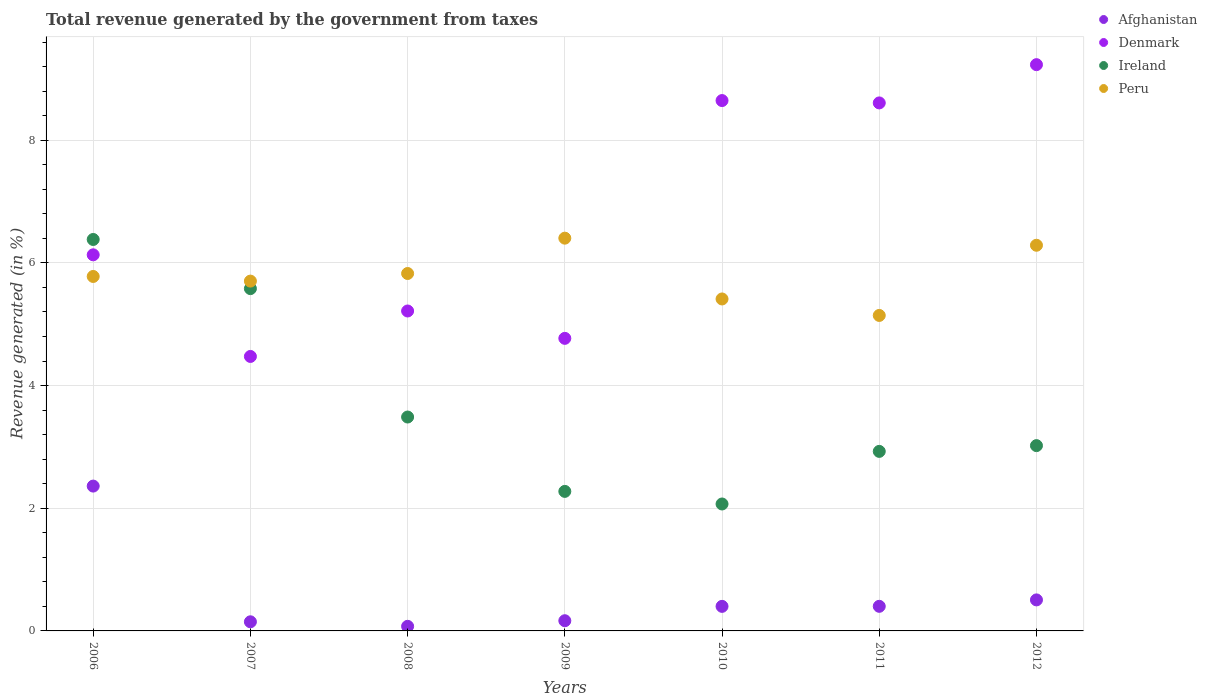How many different coloured dotlines are there?
Give a very brief answer. 4. Is the number of dotlines equal to the number of legend labels?
Offer a very short reply. Yes. What is the total revenue generated in Ireland in 2011?
Your answer should be compact. 2.93. Across all years, what is the maximum total revenue generated in Afghanistan?
Your response must be concise. 2.36. Across all years, what is the minimum total revenue generated in Peru?
Your answer should be compact. 5.14. What is the total total revenue generated in Denmark in the graph?
Your answer should be very brief. 47.08. What is the difference between the total revenue generated in Peru in 2007 and that in 2009?
Offer a very short reply. -0.7. What is the difference between the total revenue generated in Denmark in 2012 and the total revenue generated in Afghanistan in 2008?
Your answer should be compact. 9.16. What is the average total revenue generated in Afghanistan per year?
Offer a very short reply. 0.58. In the year 2006, what is the difference between the total revenue generated in Ireland and total revenue generated in Peru?
Offer a very short reply. 0.6. In how many years, is the total revenue generated in Denmark greater than 0.8 %?
Your answer should be compact. 7. What is the ratio of the total revenue generated in Denmark in 2010 to that in 2012?
Your answer should be compact. 0.94. Is the difference between the total revenue generated in Ireland in 2008 and 2011 greater than the difference between the total revenue generated in Peru in 2008 and 2011?
Make the answer very short. No. What is the difference between the highest and the second highest total revenue generated in Afghanistan?
Offer a terse response. 1.86. What is the difference between the highest and the lowest total revenue generated in Afghanistan?
Your answer should be very brief. 2.29. Is it the case that in every year, the sum of the total revenue generated in Afghanistan and total revenue generated in Peru  is greater than the total revenue generated in Ireland?
Provide a short and direct response. Yes. Does the total revenue generated in Ireland monotonically increase over the years?
Your response must be concise. No. Is the total revenue generated in Afghanistan strictly less than the total revenue generated in Denmark over the years?
Give a very brief answer. Yes. How many dotlines are there?
Offer a very short reply. 4. How many years are there in the graph?
Provide a short and direct response. 7. Does the graph contain any zero values?
Keep it short and to the point. No. Where does the legend appear in the graph?
Your answer should be very brief. Top right. How many legend labels are there?
Your answer should be very brief. 4. What is the title of the graph?
Your answer should be very brief. Total revenue generated by the government from taxes. Does "Bosnia and Herzegovina" appear as one of the legend labels in the graph?
Provide a succinct answer. No. What is the label or title of the X-axis?
Keep it short and to the point. Years. What is the label or title of the Y-axis?
Your answer should be very brief. Revenue generated (in %). What is the Revenue generated (in %) of Afghanistan in 2006?
Offer a very short reply. 2.36. What is the Revenue generated (in %) in Denmark in 2006?
Offer a very short reply. 6.13. What is the Revenue generated (in %) in Ireland in 2006?
Provide a short and direct response. 6.38. What is the Revenue generated (in %) in Peru in 2006?
Provide a succinct answer. 5.78. What is the Revenue generated (in %) in Afghanistan in 2007?
Provide a short and direct response. 0.15. What is the Revenue generated (in %) in Denmark in 2007?
Make the answer very short. 4.47. What is the Revenue generated (in %) of Ireland in 2007?
Provide a succinct answer. 5.58. What is the Revenue generated (in %) of Peru in 2007?
Keep it short and to the point. 5.7. What is the Revenue generated (in %) in Afghanistan in 2008?
Give a very brief answer. 0.08. What is the Revenue generated (in %) in Denmark in 2008?
Your answer should be compact. 5.22. What is the Revenue generated (in %) of Ireland in 2008?
Make the answer very short. 3.49. What is the Revenue generated (in %) of Peru in 2008?
Keep it short and to the point. 5.83. What is the Revenue generated (in %) of Afghanistan in 2009?
Offer a terse response. 0.17. What is the Revenue generated (in %) in Denmark in 2009?
Keep it short and to the point. 4.77. What is the Revenue generated (in %) in Ireland in 2009?
Keep it short and to the point. 2.27. What is the Revenue generated (in %) of Peru in 2009?
Keep it short and to the point. 6.4. What is the Revenue generated (in %) of Afghanistan in 2010?
Provide a short and direct response. 0.4. What is the Revenue generated (in %) of Denmark in 2010?
Offer a very short reply. 8.65. What is the Revenue generated (in %) of Ireland in 2010?
Keep it short and to the point. 2.07. What is the Revenue generated (in %) of Peru in 2010?
Give a very brief answer. 5.41. What is the Revenue generated (in %) in Afghanistan in 2011?
Your answer should be compact. 0.4. What is the Revenue generated (in %) of Denmark in 2011?
Provide a short and direct response. 8.61. What is the Revenue generated (in %) of Ireland in 2011?
Offer a very short reply. 2.93. What is the Revenue generated (in %) of Peru in 2011?
Offer a terse response. 5.14. What is the Revenue generated (in %) of Afghanistan in 2012?
Your response must be concise. 0.51. What is the Revenue generated (in %) of Denmark in 2012?
Provide a succinct answer. 9.23. What is the Revenue generated (in %) in Ireland in 2012?
Offer a terse response. 3.02. What is the Revenue generated (in %) of Peru in 2012?
Make the answer very short. 6.29. Across all years, what is the maximum Revenue generated (in %) in Afghanistan?
Keep it short and to the point. 2.36. Across all years, what is the maximum Revenue generated (in %) in Denmark?
Your answer should be very brief. 9.23. Across all years, what is the maximum Revenue generated (in %) of Ireland?
Ensure brevity in your answer.  6.38. Across all years, what is the maximum Revenue generated (in %) in Peru?
Offer a very short reply. 6.4. Across all years, what is the minimum Revenue generated (in %) of Afghanistan?
Your response must be concise. 0.08. Across all years, what is the minimum Revenue generated (in %) of Denmark?
Keep it short and to the point. 4.47. Across all years, what is the minimum Revenue generated (in %) of Ireland?
Offer a very short reply. 2.07. Across all years, what is the minimum Revenue generated (in %) in Peru?
Your answer should be very brief. 5.14. What is the total Revenue generated (in %) in Afghanistan in the graph?
Offer a very short reply. 4.06. What is the total Revenue generated (in %) of Denmark in the graph?
Provide a short and direct response. 47.08. What is the total Revenue generated (in %) of Ireland in the graph?
Offer a terse response. 25.74. What is the total Revenue generated (in %) of Peru in the graph?
Give a very brief answer. 40.55. What is the difference between the Revenue generated (in %) in Afghanistan in 2006 and that in 2007?
Provide a succinct answer. 2.21. What is the difference between the Revenue generated (in %) in Denmark in 2006 and that in 2007?
Offer a very short reply. 1.66. What is the difference between the Revenue generated (in %) in Ireland in 2006 and that in 2007?
Make the answer very short. 0.8. What is the difference between the Revenue generated (in %) of Peru in 2006 and that in 2007?
Offer a terse response. 0.08. What is the difference between the Revenue generated (in %) in Afghanistan in 2006 and that in 2008?
Keep it short and to the point. 2.29. What is the difference between the Revenue generated (in %) in Denmark in 2006 and that in 2008?
Make the answer very short. 0.92. What is the difference between the Revenue generated (in %) of Ireland in 2006 and that in 2008?
Provide a short and direct response. 2.89. What is the difference between the Revenue generated (in %) of Peru in 2006 and that in 2008?
Your answer should be compact. -0.05. What is the difference between the Revenue generated (in %) of Afghanistan in 2006 and that in 2009?
Your answer should be very brief. 2.19. What is the difference between the Revenue generated (in %) in Denmark in 2006 and that in 2009?
Provide a short and direct response. 1.36. What is the difference between the Revenue generated (in %) in Ireland in 2006 and that in 2009?
Offer a very short reply. 4.11. What is the difference between the Revenue generated (in %) in Peru in 2006 and that in 2009?
Offer a terse response. -0.62. What is the difference between the Revenue generated (in %) of Afghanistan in 2006 and that in 2010?
Make the answer very short. 1.96. What is the difference between the Revenue generated (in %) in Denmark in 2006 and that in 2010?
Ensure brevity in your answer.  -2.51. What is the difference between the Revenue generated (in %) of Ireland in 2006 and that in 2010?
Offer a very short reply. 4.31. What is the difference between the Revenue generated (in %) in Peru in 2006 and that in 2010?
Your answer should be compact. 0.37. What is the difference between the Revenue generated (in %) of Afghanistan in 2006 and that in 2011?
Your answer should be very brief. 1.96. What is the difference between the Revenue generated (in %) in Denmark in 2006 and that in 2011?
Make the answer very short. -2.48. What is the difference between the Revenue generated (in %) in Ireland in 2006 and that in 2011?
Your answer should be compact. 3.45. What is the difference between the Revenue generated (in %) in Peru in 2006 and that in 2011?
Make the answer very short. 0.64. What is the difference between the Revenue generated (in %) of Afghanistan in 2006 and that in 2012?
Give a very brief answer. 1.86. What is the difference between the Revenue generated (in %) of Denmark in 2006 and that in 2012?
Ensure brevity in your answer.  -3.1. What is the difference between the Revenue generated (in %) of Ireland in 2006 and that in 2012?
Your answer should be very brief. 3.36. What is the difference between the Revenue generated (in %) of Peru in 2006 and that in 2012?
Your answer should be very brief. -0.51. What is the difference between the Revenue generated (in %) in Afghanistan in 2007 and that in 2008?
Your answer should be very brief. 0.07. What is the difference between the Revenue generated (in %) of Denmark in 2007 and that in 2008?
Your response must be concise. -0.74. What is the difference between the Revenue generated (in %) of Ireland in 2007 and that in 2008?
Make the answer very short. 2.09. What is the difference between the Revenue generated (in %) in Peru in 2007 and that in 2008?
Keep it short and to the point. -0.12. What is the difference between the Revenue generated (in %) in Afghanistan in 2007 and that in 2009?
Ensure brevity in your answer.  -0.02. What is the difference between the Revenue generated (in %) in Denmark in 2007 and that in 2009?
Your response must be concise. -0.29. What is the difference between the Revenue generated (in %) of Ireland in 2007 and that in 2009?
Your answer should be compact. 3.31. What is the difference between the Revenue generated (in %) in Peru in 2007 and that in 2009?
Ensure brevity in your answer.  -0.7. What is the difference between the Revenue generated (in %) of Afghanistan in 2007 and that in 2010?
Offer a terse response. -0.25. What is the difference between the Revenue generated (in %) of Denmark in 2007 and that in 2010?
Provide a short and direct response. -4.17. What is the difference between the Revenue generated (in %) in Ireland in 2007 and that in 2010?
Make the answer very short. 3.51. What is the difference between the Revenue generated (in %) in Peru in 2007 and that in 2010?
Give a very brief answer. 0.29. What is the difference between the Revenue generated (in %) in Afghanistan in 2007 and that in 2011?
Give a very brief answer. -0.25. What is the difference between the Revenue generated (in %) of Denmark in 2007 and that in 2011?
Provide a succinct answer. -4.13. What is the difference between the Revenue generated (in %) of Ireland in 2007 and that in 2011?
Offer a very short reply. 2.65. What is the difference between the Revenue generated (in %) of Peru in 2007 and that in 2011?
Ensure brevity in your answer.  0.56. What is the difference between the Revenue generated (in %) of Afghanistan in 2007 and that in 2012?
Your response must be concise. -0.36. What is the difference between the Revenue generated (in %) in Denmark in 2007 and that in 2012?
Provide a succinct answer. -4.76. What is the difference between the Revenue generated (in %) in Ireland in 2007 and that in 2012?
Make the answer very short. 2.56. What is the difference between the Revenue generated (in %) of Peru in 2007 and that in 2012?
Your answer should be compact. -0.58. What is the difference between the Revenue generated (in %) of Afghanistan in 2008 and that in 2009?
Your answer should be very brief. -0.09. What is the difference between the Revenue generated (in %) in Denmark in 2008 and that in 2009?
Provide a short and direct response. 0.45. What is the difference between the Revenue generated (in %) of Ireland in 2008 and that in 2009?
Your response must be concise. 1.21. What is the difference between the Revenue generated (in %) of Peru in 2008 and that in 2009?
Your response must be concise. -0.58. What is the difference between the Revenue generated (in %) of Afghanistan in 2008 and that in 2010?
Give a very brief answer. -0.33. What is the difference between the Revenue generated (in %) in Denmark in 2008 and that in 2010?
Ensure brevity in your answer.  -3.43. What is the difference between the Revenue generated (in %) of Ireland in 2008 and that in 2010?
Your answer should be compact. 1.42. What is the difference between the Revenue generated (in %) of Peru in 2008 and that in 2010?
Keep it short and to the point. 0.42. What is the difference between the Revenue generated (in %) of Afghanistan in 2008 and that in 2011?
Offer a very short reply. -0.33. What is the difference between the Revenue generated (in %) in Denmark in 2008 and that in 2011?
Offer a very short reply. -3.39. What is the difference between the Revenue generated (in %) in Ireland in 2008 and that in 2011?
Provide a succinct answer. 0.56. What is the difference between the Revenue generated (in %) in Peru in 2008 and that in 2011?
Your answer should be very brief. 0.68. What is the difference between the Revenue generated (in %) in Afghanistan in 2008 and that in 2012?
Provide a short and direct response. -0.43. What is the difference between the Revenue generated (in %) of Denmark in 2008 and that in 2012?
Provide a succinct answer. -4.02. What is the difference between the Revenue generated (in %) in Ireland in 2008 and that in 2012?
Provide a succinct answer. 0.47. What is the difference between the Revenue generated (in %) of Peru in 2008 and that in 2012?
Offer a terse response. -0.46. What is the difference between the Revenue generated (in %) in Afghanistan in 2009 and that in 2010?
Your answer should be very brief. -0.23. What is the difference between the Revenue generated (in %) of Denmark in 2009 and that in 2010?
Make the answer very short. -3.88. What is the difference between the Revenue generated (in %) of Ireland in 2009 and that in 2010?
Your answer should be compact. 0.21. What is the difference between the Revenue generated (in %) of Afghanistan in 2009 and that in 2011?
Give a very brief answer. -0.23. What is the difference between the Revenue generated (in %) in Denmark in 2009 and that in 2011?
Offer a very short reply. -3.84. What is the difference between the Revenue generated (in %) in Ireland in 2009 and that in 2011?
Your response must be concise. -0.65. What is the difference between the Revenue generated (in %) in Peru in 2009 and that in 2011?
Your answer should be compact. 1.26. What is the difference between the Revenue generated (in %) of Afghanistan in 2009 and that in 2012?
Provide a succinct answer. -0.34. What is the difference between the Revenue generated (in %) of Denmark in 2009 and that in 2012?
Give a very brief answer. -4.46. What is the difference between the Revenue generated (in %) in Ireland in 2009 and that in 2012?
Make the answer very short. -0.75. What is the difference between the Revenue generated (in %) of Peru in 2009 and that in 2012?
Keep it short and to the point. 0.12. What is the difference between the Revenue generated (in %) in Afghanistan in 2010 and that in 2011?
Your answer should be compact. -0. What is the difference between the Revenue generated (in %) of Denmark in 2010 and that in 2011?
Your answer should be compact. 0.04. What is the difference between the Revenue generated (in %) of Ireland in 2010 and that in 2011?
Make the answer very short. -0.86. What is the difference between the Revenue generated (in %) in Peru in 2010 and that in 2011?
Provide a succinct answer. 0.27. What is the difference between the Revenue generated (in %) in Afghanistan in 2010 and that in 2012?
Keep it short and to the point. -0.11. What is the difference between the Revenue generated (in %) of Denmark in 2010 and that in 2012?
Offer a very short reply. -0.59. What is the difference between the Revenue generated (in %) in Ireland in 2010 and that in 2012?
Offer a very short reply. -0.95. What is the difference between the Revenue generated (in %) of Peru in 2010 and that in 2012?
Your answer should be compact. -0.88. What is the difference between the Revenue generated (in %) of Afghanistan in 2011 and that in 2012?
Offer a terse response. -0.1. What is the difference between the Revenue generated (in %) in Denmark in 2011 and that in 2012?
Your answer should be very brief. -0.62. What is the difference between the Revenue generated (in %) in Ireland in 2011 and that in 2012?
Keep it short and to the point. -0.09. What is the difference between the Revenue generated (in %) of Peru in 2011 and that in 2012?
Your answer should be compact. -1.14. What is the difference between the Revenue generated (in %) in Afghanistan in 2006 and the Revenue generated (in %) in Denmark in 2007?
Make the answer very short. -2.11. What is the difference between the Revenue generated (in %) in Afghanistan in 2006 and the Revenue generated (in %) in Ireland in 2007?
Make the answer very short. -3.22. What is the difference between the Revenue generated (in %) in Afghanistan in 2006 and the Revenue generated (in %) in Peru in 2007?
Provide a succinct answer. -3.34. What is the difference between the Revenue generated (in %) in Denmark in 2006 and the Revenue generated (in %) in Ireland in 2007?
Make the answer very short. 0.55. What is the difference between the Revenue generated (in %) of Denmark in 2006 and the Revenue generated (in %) of Peru in 2007?
Offer a terse response. 0.43. What is the difference between the Revenue generated (in %) of Ireland in 2006 and the Revenue generated (in %) of Peru in 2007?
Make the answer very short. 0.68. What is the difference between the Revenue generated (in %) of Afghanistan in 2006 and the Revenue generated (in %) of Denmark in 2008?
Provide a succinct answer. -2.85. What is the difference between the Revenue generated (in %) in Afghanistan in 2006 and the Revenue generated (in %) in Ireland in 2008?
Keep it short and to the point. -1.13. What is the difference between the Revenue generated (in %) of Afghanistan in 2006 and the Revenue generated (in %) of Peru in 2008?
Make the answer very short. -3.47. What is the difference between the Revenue generated (in %) of Denmark in 2006 and the Revenue generated (in %) of Ireland in 2008?
Ensure brevity in your answer.  2.64. What is the difference between the Revenue generated (in %) of Denmark in 2006 and the Revenue generated (in %) of Peru in 2008?
Ensure brevity in your answer.  0.3. What is the difference between the Revenue generated (in %) of Ireland in 2006 and the Revenue generated (in %) of Peru in 2008?
Offer a terse response. 0.55. What is the difference between the Revenue generated (in %) of Afghanistan in 2006 and the Revenue generated (in %) of Denmark in 2009?
Your response must be concise. -2.41. What is the difference between the Revenue generated (in %) in Afghanistan in 2006 and the Revenue generated (in %) in Ireland in 2009?
Provide a short and direct response. 0.09. What is the difference between the Revenue generated (in %) of Afghanistan in 2006 and the Revenue generated (in %) of Peru in 2009?
Give a very brief answer. -4.04. What is the difference between the Revenue generated (in %) of Denmark in 2006 and the Revenue generated (in %) of Ireland in 2009?
Make the answer very short. 3.86. What is the difference between the Revenue generated (in %) in Denmark in 2006 and the Revenue generated (in %) in Peru in 2009?
Ensure brevity in your answer.  -0.27. What is the difference between the Revenue generated (in %) in Ireland in 2006 and the Revenue generated (in %) in Peru in 2009?
Your response must be concise. -0.02. What is the difference between the Revenue generated (in %) in Afghanistan in 2006 and the Revenue generated (in %) in Denmark in 2010?
Your answer should be very brief. -6.29. What is the difference between the Revenue generated (in %) of Afghanistan in 2006 and the Revenue generated (in %) of Ireland in 2010?
Make the answer very short. 0.29. What is the difference between the Revenue generated (in %) of Afghanistan in 2006 and the Revenue generated (in %) of Peru in 2010?
Your answer should be very brief. -3.05. What is the difference between the Revenue generated (in %) in Denmark in 2006 and the Revenue generated (in %) in Ireland in 2010?
Your response must be concise. 4.06. What is the difference between the Revenue generated (in %) of Denmark in 2006 and the Revenue generated (in %) of Peru in 2010?
Give a very brief answer. 0.72. What is the difference between the Revenue generated (in %) in Ireland in 2006 and the Revenue generated (in %) in Peru in 2010?
Make the answer very short. 0.97. What is the difference between the Revenue generated (in %) of Afghanistan in 2006 and the Revenue generated (in %) of Denmark in 2011?
Keep it short and to the point. -6.25. What is the difference between the Revenue generated (in %) of Afghanistan in 2006 and the Revenue generated (in %) of Ireland in 2011?
Provide a short and direct response. -0.57. What is the difference between the Revenue generated (in %) of Afghanistan in 2006 and the Revenue generated (in %) of Peru in 2011?
Give a very brief answer. -2.78. What is the difference between the Revenue generated (in %) in Denmark in 2006 and the Revenue generated (in %) in Ireland in 2011?
Provide a short and direct response. 3.2. What is the difference between the Revenue generated (in %) of Denmark in 2006 and the Revenue generated (in %) of Peru in 2011?
Your response must be concise. 0.99. What is the difference between the Revenue generated (in %) in Ireland in 2006 and the Revenue generated (in %) in Peru in 2011?
Make the answer very short. 1.24. What is the difference between the Revenue generated (in %) in Afghanistan in 2006 and the Revenue generated (in %) in Denmark in 2012?
Make the answer very short. -6.87. What is the difference between the Revenue generated (in %) in Afghanistan in 2006 and the Revenue generated (in %) in Ireland in 2012?
Give a very brief answer. -0.66. What is the difference between the Revenue generated (in %) in Afghanistan in 2006 and the Revenue generated (in %) in Peru in 2012?
Your answer should be compact. -3.93. What is the difference between the Revenue generated (in %) of Denmark in 2006 and the Revenue generated (in %) of Ireland in 2012?
Your answer should be compact. 3.11. What is the difference between the Revenue generated (in %) of Denmark in 2006 and the Revenue generated (in %) of Peru in 2012?
Provide a short and direct response. -0.16. What is the difference between the Revenue generated (in %) of Ireland in 2006 and the Revenue generated (in %) of Peru in 2012?
Give a very brief answer. 0.09. What is the difference between the Revenue generated (in %) of Afghanistan in 2007 and the Revenue generated (in %) of Denmark in 2008?
Your answer should be very brief. -5.07. What is the difference between the Revenue generated (in %) in Afghanistan in 2007 and the Revenue generated (in %) in Ireland in 2008?
Offer a very short reply. -3.34. What is the difference between the Revenue generated (in %) in Afghanistan in 2007 and the Revenue generated (in %) in Peru in 2008?
Your answer should be very brief. -5.68. What is the difference between the Revenue generated (in %) in Denmark in 2007 and the Revenue generated (in %) in Peru in 2008?
Your response must be concise. -1.35. What is the difference between the Revenue generated (in %) of Ireland in 2007 and the Revenue generated (in %) of Peru in 2008?
Make the answer very short. -0.25. What is the difference between the Revenue generated (in %) of Afghanistan in 2007 and the Revenue generated (in %) of Denmark in 2009?
Offer a terse response. -4.62. What is the difference between the Revenue generated (in %) in Afghanistan in 2007 and the Revenue generated (in %) in Ireland in 2009?
Make the answer very short. -2.13. What is the difference between the Revenue generated (in %) in Afghanistan in 2007 and the Revenue generated (in %) in Peru in 2009?
Make the answer very short. -6.25. What is the difference between the Revenue generated (in %) in Denmark in 2007 and the Revenue generated (in %) in Peru in 2009?
Keep it short and to the point. -1.93. What is the difference between the Revenue generated (in %) of Ireland in 2007 and the Revenue generated (in %) of Peru in 2009?
Provide a succinct answer. -0.82. What is the difference between the Revenue generated (in %) of Afghanistan in 2007 and the Revenue generated (in %) of Denmark in 2010?
Make the answer very short. -8.5. What is the difference between the Revenue generated (in %) in Afghanistan in 2007 and the Revenue generated (in %) in Ireland in 2010?
Provide a succinct answer. -1.92. What is the difference between the Revenue generated (in %) of Afghanistan in 2007 and the Revenue generated (in %) of Peru in 2010?
Your answer should be compact. -5.26. What is the difference between the Revenue generated (in %) in Denmark in 2007 and the Revenue generated (in %) in Ireland in 2010?
Your answer should be very brief. 2.41. What is the difference between the Revenue generated (in %) in Denmark in 2007 and the Revenue generated (in %) in Peru in 2010?
Provide a succinct answer. -0.94. What is the difference between the Revenue generated (in %) of Ireland in 2007 and the Revenue generated (in %) of Peru in 2010?
Make the answer very short. 0.17. What is the difference between the Revenue generated (in %) of Afghanistan in 2007 and the Revenue generated (in %) of Denmark in 2011?
Keep it short and to the point. -8.46. What is the difference between the Revenue generated (in %) in Afghanistan in 2007 and the Revenue generated (in %) in Ireland in 2011?
Provide a succinct answer. -2.78. What is the difference between the Revenue generated (in %) in Afghanistan in 2007 and the Revenue generated (in %) in Peru in 2011?
Keep it short and to the point. -4.99. What is the difference between the Revenue generated (in %) of Denmark in 2007 and the Revenue generated (in %) of Ireland in 2011?
Your answer should be compact. 1.55. What is the difference between the Revenue generated (in %) of Denmark in 2007 and the Revenue generated (in %) of Peru in 2011?
Offer a terse response. -0.67. What is the difference between the Revenue generated (in %) of Ireland in 2007 and the Revenue generated (in %) of Peru in 2011?
Offer a terse response. 0.44. What is the difference between the Revenue generated (in %) of Afghanistan in 2007 and the Revenue generated (in %) of Denmark in 2012?
Your answer should be compact. -9.08. What is the difference between the Revenue generated (in %) in Afghanistan in 2007 and the Revenue generated (in %) in Ireland in 2012?
Ensure brevity in your answer.  -2.87. What is the difference between the Revenue generated (in %) in Afghanistan in 2007 and the Revenue generated (in %) in Peru in 2012?
Your response must be concise. -6.14. What is the difference between the Revenue generated (in %) of Denmark in 2007 and the Revenue generated (in %) of Ireland in 2012?
Provide a short and direct response. 1.45. What is the difference between the Revenue generated (in %) in Denmark in 2007 and the Revenue generated (in %) in Peru in 2012?
Provide a succinct answer. -1.81. What is the difference between the Revenue generated (in %) in Ireland in 2007 and the Revenue generated (in %) in Peru in 2012?
Offer a very short reply. -0.71. What is the difference between the Revenue generated (in %) of Afghanistan in 2008 and the Revenue generated (in %) of Denmark in 2009?
Provide a short and direct response. -4.69. What is the difference between the Revenue generated (in %) in Afghanistan in 2008 and the Revenue generated (in %) in Ireland in 2009?
Ensure brevity in your answer.  -2.2. What is the difference between the Revenue generated (in %) of Afghanistan in 2008 and the Revenue generated (in %) of Peru in 2009?
Provide a succinct answer. -6.33. What is the difference between the Revenue generated (in %) in Denmark in 2008 and the Revenue generated (in %) in Ireland in 2009?
Offer a very short reply. 2.94. What is the difference between the Revenue generated (in %) of Denmark in 2008 and the Revenue generated (in %) of Peru in 2009?
Offer a very short reply. -1.19. What is the difference between the Revenue generated (in %) of Ireland in 2008 and the Revenue generated (in %) of Peru in 2009?
Provide a succinct answer. -2.92. What is the difference between the Revenue generated (in %) in Afghanistan in 2008 and the Revenue generated (in %) in Denmark in 2010?
Make the answer very short. -8.57. What is the difference between the Revenue generated (in %) in Afghanistan in 2008 and the Revenue generated (in %) in Ireland in 2010?
Provide a short and direct response. -1.99. What is the difference between the Revenue generated (in %) of Afghanistan in 2008 and the Revenue generated (in %) of Peru in 2010?
Your answer should be very brief. -5.34. What is the difference between the Revenue generated (in %) in Denmark in 2008 and the Revenue generated (in %) in Ireland in 2010?
Give a very brief answer. 3.15. What is the difference between the Revenue generated (in %) of Denmark in 2008 and the Revenue generated (in %) of Peru in 2010?
Offer a very short reply. -0.2. What is the difference between the Revenue generated (in %) in Ireland in 2008 and the Revenue generated (in %) in Peru in 2010?
Provide a short and direct response. -1.92. What is the difference between the Revenue generated (in %) of Afghanistan in 2008 and the Revenue generated (in %) of Denmark in 2011?
Your answer should be compact. -8.53. What is the difference between the Revenue generated (in %) of Afghanistan in 2008 and the Revenue generated (in %) of Ireland in 2011?
Your response must be concise. -2.85. What is the difference between the Revenue generated (in %) of Afghanistan in 2008 and the Revenue generated (in %) of Peru in 2011?
Give a very brief answer. -5.07. What is the difference between the Revenue generated (in %) in Denmark in 2008 and the Revenue generated (in %) in Ireland in 2011?
Offer a very short reply. 2.29. What is the difference between the Revenue generated (in %) of Denmark in 2008 and the Revenue generated (in %) of Peru in 2011?
Offer a very short reply. 0.07. What is the difference between the Revenue generated (in %) of Ireland in 2008 and the Revenue generated (in %) of Peru in 2011?
Offer a very short reply. -1.66. What is the difference between the Revenue generated (in %) in Afghanistan in 2008 and the Revenue generated (in %) in Denmark in 2012?
Give a very brief answer. -9.16. What is the difference between the Revenue generated (in %) of Afghanistan in 2008 and the Revenue generated (in %) of Ireland in 2012?
Keep it short and to the point. -2.95. What is the difference between the Revenue generated (in %) in Afghanistan in 2008 and the Revenue generated (in %) in Peru in 2012?
Ensure brevity in your answer.  -6.21. What is the difference between the Revenue generated (in %) of Denmark in 2008 and the Revenue generated (in %) of Ireland in 2012?
Ensure brevity in your answer.  2.19. What is the difference between the Revenue generated (in %) in Denmark in 2008 and the Revenue generated (in %) in Peru in 2012?
Provide a succinct answer. -1.07. What is the difference between the Revenue generated (in %) in Ireland in 2008 and the Revenue generated (in %) in Peru in 2012?
Provide a succinct answer. -2.8. What is the difference between the Revenue generated (in %) of Afghanistan in 2009 and the Revenue generated (in %) of Denmark in 2010?
Your response must be concise. -8.48. What is the difference between the Revenue generated (in %) in Afghanistan in 2009 and the Revenue generated (in %) in Ireland in 2010?
Offer a terse response. -1.9. What is the difference between the Revenue generated (in %) in Afghanistan in 2009 and the Revenue generated (in %) in Peru in 2010?
Provide a succinct answer. -5.25. What is the difference between the Revenue generated (in %) in Denmark in 2009 and the Revenue generated (in %) in Ireland in 2010?
Provide a short and direct response. 2.7. What is the difference between the Revenue generated (in %) of Denmark in 2009 and the Revenue generated (in %) of Peru in 2010?
Provide a succinct answer. -0.64. What is the difference between the Revenue generated (in %) in Ireland in 2009 and the Revenue generated (in %) in Peru in 2010?
Offer a very short reply. -3.14. What is the difference between the Revenue generated (in %) of Afghanistan in 2009 and the Revenue generated (in %) of Denmark in 2011?
Your answer should be compact. -8.44. What is the difference between the Revenue generated (in %) in Afghanistan in 2009 and the Revenue generated (in %) in Ireland in 2011?
Your response must be concise. -2.76. What is the difference between the Revenue generated (in %) of Afghanistan in 2009 and the Revenue generated (in %) of Peru in 2011?
Provide a short and direct response. -4.98. What is the difference between the Revenue generated (in %) of Denmark in 2009 and the Revenue generated (in %) of Ireland in 2011?
Provide a short and direct response. 1.84. What is the difference between the Revenue generated (in %) in Denmark in 2009 and the Revenue generated (in %) in Peru in 2011?
Offer a very short reply. -0.37. What is the difference between the Revenue generated (in %) in Ireland in 2009 and the Revenue generated (in %) in Peru in 2011?
Keep it short and to the point. -2.87. What is the difference between the Revenue generated (in %) of Afghanistan in 2009 and the Revenue generated (in %) of Denmark in 2012?
Keep it short and to the point. -9.07. What is the difference between the Revenue generated (in %) of Afghanistan in 2009 and the Revenue generated (in %) of Ireland in 2012?
Offer a very short reply. -2.85. What is the difference between the Revenue generated (in %) of Afghanistan in 2009 and the Revenue generated (in %) of Peru in 2012?
Ensure brevity in your answer.  -6.12. What is the difference between the Revenue generated (in %) in Denmark in 2009 and the Revenue generated (in %) in Ireland in 2012?
Offer a very short reply. 1.75. What is the difference between the Revenue generated (in %) in Denmark in 2009 and the Revenue generated (in %) in Peru in 2012?
Your answer should be compact. -1.52. What is the difference between the Revenue generated (in %) of Ireland in 2009 and the Revenue generated (in %) of Peru in 2012?
Provide a short and direct response. -4.01. What is the difference between the Revenue generated (in %) in Afghanistan in 2010 and the Revenue generated (in %) in Denmark in 2011?
Provide a succinct answer. -8.21. What is the difference between the Revenue generated (in %) of Afghanistan in 2010 and the Revenue generated (in %) of Ireland in 2011?
Ensure brevity in your answer.  -2.53. What is the difference between the Revenue generated (in %) in Afghanistan in 2010 and the Revenue generated (in %) in Peru in 2011?
Keep it short and to the point. -4.74. What is the difference between the Revenue generated (in %) of Denmark in 2010 and the Revenue generated (in %) of Ireland in 2011?
Your response must be concise. 5.72. What is the difference between the Revenue generated (in %) of Denmark in 2010 and the Revenue generated (in %) of Peru in 2011?
Your answer should be very brief. 3.5. What is the difference between the Revenue generated (in %) of Ireland in 2010 and the Revenue generated (in %) of Peru in 2011?
Offer a terse response. -3.07. What is the difference between the Revenue generated (in %) of Afghanistan in 2010 and the Revenue generated (in %) of Denmark in 2012?
Make the answer very short. -8.83. What is the difference between the Revenue generated (in %) in Afghanistan in 2010 and the Revenue generated (in %) in Ireland in 2012?
Your answer should be very brief. -2.62. What is the difference between the Revenue generated (in %) in Afghanistan in 2010 and the Revenue generated (in %) in Peru in 2012?
Your response must be concise. -5.89. What is the difference between the Revenue generated (in %) of Denmark in 2010 and the Revenue generated (in %) of Ireland in 2012?
Provide a succinct answer. 5.63. What is the difference between the Revenue generated (in %) of Denmark in 2010 and the Revenue generated (in %) of Peru in 2012?
Keep it short and to the point. 2.36. What is the difference between the Revenue generated (in %) in Ireland in 2010 and the Revenue generated (in %) in Peru in 2012?
Ensure brevity in your answer.  -4.22. What is the difference between the Revenue generated (in %) in Afghanistan in 2011 and the Revenue generated (in %) in Denmark in 2012?
Make the answer very short. -8.83. What is the difference between the Revenue generated (in %) of Afghanistan in 2011 and the Revenue generated (in %) of Ireland in 2012?
Your answer should be very brief. -2.62. What is the difference between the Revenue generated (in %) of Afghanistan in 2011 and the Revenue generated (in %) of Peru in 2012?
Give a very brief answer. -5.89. What is the difference between the Revenue generated (in %) in Denmark in 2011 and the Revenue generated (in %) in Ireland in 2012?
Keep it short and to the point. 5.59. What is the difference between the Revenue generated (in %) in Denmark in 2011 and the Revenue generated (in %) in Peru in 2012?
Make the answer very short. 2.32. What is the difference between the Revenue generated (in %) of Ireland in 2011 and the Revenue generated (in %) of Peru in 2012?
Offer a terse response. -3.36. What is the average Revenue generated (in %) in Afghanistan per year?
Your response must be concise. 0.58. What is the average Revenue generated (in %) in Denmark per year?
Your answer should be compact. 6.73. What is the average Revenue generated (in %) in Ireland per year?
Keep it short and to the point. 3.68. What is the average Revenue generated (in %) of Peru per year?
Your answer should be very brief. 5.79. In the year 2006, what is the difference between the Revenue generated (in %) of Afghanistan and Revenue generated (in %) of Denmark?
Your answer should be compact. -3.77. In the year 2006, what is the difference between the Revenue generated (in %) of Afghanistan and Revenue generated (in %) of Ireland?
Provide a succinct answer. -4.02. In the year 2006, what is the difference between the Revenue generated (in %) of Afghanistan and Revenue generated (in %) of Peru?
Your response must be concise. -3.42. In the year 2006, what is the difference between the Revenue generated (in %) in Denmark and Revenue generated (in %) in Ireland?
Offer a very short reply. -0.25. In the year 2006, what is the difference between the Revenue generated (in %) in Denmark and Revenue generated (in %) in Peru?
Offer a very short reply. 0.35. In the year 2006, what is the difference between the Revenue generated (in %) in Ireland and Revenue generated (in %) in Peru?
Provide a short and direct response. 0.6. In the year 2007, what is the difference between the Revenue generated (in %) of Afghanistan and Revenue generated (in %) of Denmark?
Provide a short and direct response. -4.33. In the year 2007, what is the difference between the Revenue generated (in %) in Afghanistan and Revenue generated (in %) in Ireland?
Make the answer very short. -5.43. In the year 2007, what is the difference between the Revenue generated (in %) of Afghanistan and Revenue generated (in %) of Peru?
Offer a very short reply. -5.55. In the year 2007, what is the difference between the Revenue generated (in %) in Denmark and Revenue generated (in %) in Ireland?
Your response must be concise. -1.11. In the year 2007, what is the difference between the Revenue generated (in %) of Denmark and Revenue generated (in %) of Peru?
Keep it short and to the point. -1.23. In the year 2007, what is the difference between the Revenue generated (in %) in Ireland and Revenue generated (in %) in Peru?
Provide a succinct answer. -0.12. In the year 2008, what is the difference between the Revenue generated (in %) in Afghanistan and Revenue generated (in %) in Denmark?
Your answer should be compact. -5.14. In the year 2008, what is the difference between the Revenue generated (in %) of Afghanistan and Revenue generated (in %) of Ireland?
Keep it short and to the point. -3.41. In the year 2008, what is the difference between the Revenue generated (in %) of Afghanistan and Revenue generated (in %) of Peru?
Your response must be concise. -5.75. In the year 2008, what is the difference between the Revenue generated (in %) of Denmark and Revenue generated (in %) of Ireland?
Give a very brief answer. 1.73. In the year 2008, what is the difference between the Revenue generated (in %) of Denmark and Revenue generated (in %) of Peru?
Offer a terse response. -0.61. In the year 2008, what is the difference between the Revenue generated (in %) in Ireland and Revenue generated (in %) in Peru?
Your response must be concise. -2.34. In the year 2009, what is the difference between the Revenue generated (in %) of Afghanistan and Revenue generated (in %) of Denmark?
Your answer should be compact. -4.6. In the year 2009, what is the difference between the Revenue generated (in %) in Afghanistan and Revenue generated (in %) in Ireland?
Your answer should be compact. -2.11. In the year 2009, what is the difference between the Revenue generated (in %) of Afghanistan and Revenue generated (in %) of Peru?
Provide a succinct answer. -6.24. In the year 2009, what is the difference between the Revenue generated (in %) of Denmark and Revenue generated (in %) of Ireland?
Give a very brief answer. 2.49. In the year 2009, what is the difference between the Revenue generated (in %) of Denmark and Revenue generated (in %) of Peru?
Make the answer very short. -1.63. In the year 2009, what is the difference between the Revenue generated (in %) of Ireland and Revenue generated (in %) of Peru?
Make the answer very short. -4.13. In the year 2010, what is the difference between the Revenue generated (in %) in Afghanistan and Revenue generated (in %) in Denmark?
Keep it short and to the point. -8.25. In the year 2010, what is the difference between the Revenue generated (in %) in Afghanistan and Revenue generated (in %) in Ireland?
Offer a very short reply. -1.67. In the year 2010, what is the difference between the Revenue generated (in %) in Afghanistan and Revenue generated (in %) in Peru?
Keep it short and to the point. -5.01. In the year 2010, what is the difference between the Revenue generated (in %) in Denmark and Revenue generated (in %) in Ireland?
Make the answer very short. 6.58. In the year 2010, what is the difference between the Revenue generated (in %) in Denmark and Revenue generated (in %) in Peru?
Provide a succinct answer. 3.23. In the year 2010, what is the difference between the Revenue generated (in %) in Ireland and Revenue generated (in %) in Peru?
Your answer should be compact. -3.34. In the year 2011, what is the difference between the Revenue generated (in %) of Afghanistan and Revenue generated (in %) of Denmark?
Ensure brevity in your answer.  -8.21. In the year 2011, what is the difference between the Revenue generated (in %) of Afghanistan and Revenue generated (in %) of Ireland?
Give a very brief answer. -2.53. In the year 2011, what is the difference between the Revenue generated (in %) of Afghanistan and Revenue generated (in %) of Peru?
Offer a very short reply. -4.74. In the year 2011, what is the difference between the Revenue generated (in %) of Denmark and Revenue generated (in %) of Ireland?
Ensure brevity in your answer.  5.68. In the year 2011, what is the difference between the Revenue generated (in %) of Denmark and Revenue generated (in %) of Peru?
Give a very brief answer. 3.46. In the year 2011, what is the difference between the Revenue generated (in %) of Ireland and Revenue generated (in %) of Peru?
Your answer should be compact. -2.22. In the year 2012, what is the difference between the Revenue generated (in %) in Afghanistan and Revenue generated (in %) in Denmark?
Your response must be concise. -8.73. In the year 2012, what is the difference between the Revenue generated (in %) of Afghanistan and Revenue generated (in %) of Ireland?
Keep it short and to the point. -2.52. In the year 2012, what is the difference between the Revenue generated (in %) of Afghanistan and Revenue generated (in %) of Peru?
Provide a succinct answer. -5.78. In the year 2012, what is the difference between the Revenue generated (in %) in Denmark and Revenue generated (in %) in Ireland?
Provide a short and direct response. 6.21. In the year 2012, what is the difference between the Revenue generated (in %) in Denmark and Revenue generated (in %) in Peru?
Ensure brevity in your answer.  2.94. In the year 2012, what is the difference between the Revenue generated (in %) of Ireland and Revenue generated (in %) of Peru?
Give a very brief answer. -3.27. What is the ratio of the Revenue generated (in %) of Afghanistan in 2006 to that in 2007?
Offer a very short reply. 15.87. What is the ratio of the Revenue generated (in %) of Denmark in 2006 to that in 2007?
Provide a short and direct response. 1.37. What is the ratio of the Revenue generated (in %) in Ireland in 2006 to that in 2007?
Your response must be concise. 1.14. What is the ratio of the Revenue generated (in %) of Peru in 2006 to that in 2007?
Your answer should be compact. 1.01. What is the ratio of the Revenue generated (in %) in Afghanistan in 2006 to that in 2008?
Offer a terse response. 31.44. What is the ratio of the Revenue generated (in %) in Denmark in 2006 to that in 2008?
Provide a short and direct response. 1.18. What is the ratio of the Revenue generated (in %) in Ireland in 2006 to that in 2008?
Make the answer very short. 1.83. What is the ratio of the Revenue generated (in %) of Afghanistan in 2006 to that in 2009?
Ensure brevity in your answer.  14.21. What is the ratio of the Revenue generated (in %) of Denmark in 2006 to that in 2009?
Make the answer very short. 1.29. What is the ratio of the Revenue generated (in %) of Ireland in 2006 to that in 2009?
Ensure brevity in your answer.  2.81. What is the ratio of the Revenue generated (in %) in Peru in 2006 to that in 2009?
Provide a short and direct response. 0.9. What is the ratio of the Revenue generated (in %) in Afghanistan in 2006 to that in 2010?
Provide a short and direct response. 5.9. What is the ratio of the Revenue generated (in %) in Denmark in 2006 to that in 2010?
Offer a very short reply. 0.71. What is the ratio of the Revenue generated (in %) in Ireland in 2006 to that in 2010?
Your answer should be very brief. 3.08. What is the ratio of the Revenue generated (in %) in Peru in 2006 to that in 2010?
Your answer should be compact. 1.07. What is the ratio of the Revenue generated (in %) in Afghanistan in 2006 to that in 2011?
Provide a short and direct response. 5.89. What is the ratio of the Revenue generated (in %) of Denmark in 2006 to that in 2011?
Make the answer very short. 0.71. What is the ratio of the Revenue generated (in %) of Ireland in 2006 to that in 2011?
Provide a short and direct response. 2.18. What is the ratio of the Revenue generated (in %) in Peru in 2006 to that in 2011?
Provide a short and direct response. 1.12. What is the ratio of the Revenue generated (in %) of Afghanistan in 2006 to that in 2012?
Your response must be concise. 4.67. What is the ratio of the Revenue generated (in %) of Denmark in 2006 to that in 2012?
Make the answer very short. 0.66. What is the ratio of the Revenue generated (in %) of Ireland in 2006 to that in 2012?
Your answer should be compact. 2.11. What is the ratio of the Revenue generated (in %) in Peru in 2006 to that in 2012?
Provide a short and direct response. 0.92. What is the ratio of the Revenue generated (in %) of Afghanistan in 2007 to that in 2008?
Your response must be concise. 1.98. What is the ratio of the Revenue generated (in %) of Denmark in 2007 to that in 2008?
Ensure brevity in your answer.  0.86. What is the ratio of the Revenue generated (in %) in Ireland in 2007 to that in 2008?
Give a very brief answer. 1.6. What is the ratio of the Revenue generated (in %) of Peru in 2007 to that in 2008?
Offer a terse response. 0.98. What is the ratio of the Revenue generated (in %) in Afghanistan in 2007 to that in 2009?
Offer a terse response. 0.9. What is the ratio of the Revenue generated (in %) in Denmark in 2007 to that in 2009?
Ensure brevity in your answer.  0.94. What is the ratio of the Revenue generated (in %) of Ireland in 2007 to that in 2009?
Ensure brevity in your answer.  2.45. What is the ratio of the Revenue generated (in %) of Peru in 2007 to that in 2009?
Keep it short and to the point. 0.89. What is the ratio of the Revenue generated (in %) of Afghanistan in 2007 to that in 2010?
Your answer should be very brief. 0.37. What is the ratio of the Revenue generated (in %) of Denmark in 2007 to that in 2010?
Offer a very short reply. 0.52. What is the ratio of the Revenue generated (in %) of Ireland in 2007 to that in 2010?
Ensure brevity in your answer.  2.7. What is the ratio of the Revenue generated (in %) of Peru in 2007 to that in 2010?
Keep it short and to the point. 1.05. What is the ratio of the Revenue generated (in %) in Afghanistan in 2007 to that in 2011?
Make the answer very short. 0.37. What is the ratio of the Revenue generated (in %) in Denmark in 2007 to that in 2011?
Offer a very short reply. 0.52. What is the ratio of the Revenue generated (in %) of Ireland in 2007 to that in 2011?
Offer a very short reply. 1.91. What is the ratio of the Revenue generated (in %) in Peru in 2007 to that in 2011?
Your answer should be very brief. 1.11. What is the ratio of the Revenue generated (in %) in Afghanistan in 2007 to that in 2012?
Offer a terse response. 0.29. What is the ratio of the Revenue generated (in %) of Denmark in 2007 to that in 2012?
Provide a succinct answer. 0.48. What is the ratio of the Revenue generated (in %) in Ireland in 2007 to that in 2012?
Provide a short and direct response. 1.85. What is the ratio of the Revenue generated (in %) in Peru in 2007 to that in 2012?
Your answer should be compact. 0.91. What is the ratio of the Revenue generated (in %) of Afghanistan in 2008 to that in 2009?
Keep it short and to the point. 0.45. What is the ratio of the Revenue generated (in %) in Denmark in 2008 to that in 2009?
Provide a succinct answer. 1.09. What is the ratio of the Revenue generated (in %) in Ireland in 2008 to that in 2009?
Provide a succinct answer. 1.53. What is the ratio of the Revenue generated (in %) in Peru in 2008 to that in 2009?
Your response must be concise. 0.91. What is the ratio of the Revenue generated (in %) of Afghanistan in 2008 to that in 2010?
Provide a succinct answer. 0.19. What is the ratio of the Revenue generated (in %) in Denmark in 2008 to that in 2010?
Your answer should be compact. 0.6. What is the ratio of the Revenue generated (in %) of Ireland in 2008 to that in 2010?
Make the answer very short. 1.69. What is the ratio of the Revenue generated (in %) of Peru in 2008 to that in 2010?
Ensure brevity in your answer.  1.08. What is the ratio of the Revenue generated (in %) of Afghanistan in 2008 to that in 2011?
Keep it short and to the point. 0.19. What is the ratio of the Revenue generated (in %) in Denmark in 2008 to that in 2011?
Give a very brief answer. 0.61. What is the ratio of the Revenue generated (in %) in Ireland in 2008 to that in 2011?
Ensure brevity in your answer.  1.19. What is the ratio of the Revenue generated (in %) in Peru in 2008 to that in 2011?
Give a very brief answer. 1.13. What is the ratio of the Revenue generated (in %) in Afghanistan in 2008 to that in 2012?
Your answer should be compact. 0.15. What is the ratio of the Revenue generated (in %) in Denmark in 2008 to that in 2012?
Make the answer very short. 0.56. What is the ratio of the Revenue generated (in %) in Ireland in 2008 to that in 2012?
Ensure brevity in your answer.  1.15. What is the ratio of the Revenue generated (in %) in Peru in 2008 to that in 2012?
Your answer should be compact. 0.93. What is the ratio of the Revenue generated (in %) of Afghanistan in 2009 to that in 2010?
Keep it short and to the point. 0.42. What is the ratio of the Revenue generated (in %) in Denmark in 2009 to that in 2010?
Make the answer very short. 0.55. What is the ratio of the Revenue generated (in %) in Ireland in 2009 to that in 2010?
Keep it short and to the point. 1.1. What is the ratio of the Revenue generated (in %) in Peru in 2009 to that in 2010?
Your answer should be compact. 1.18. What is the ratio of the Revenue generated (in %) of Afghanistan in 2009 to that in 2011?
Provide a short and direct response. 0.41. What is the ratio of the Revenue generated (in %) in Denmark in 2009 to that in 2011?
Ensure brevity in your answer.  0.55. What is the ratio of the Revenue generated (in %) of Ireland in 2009 to that in 2011?
Your answer should be very brief. 0.78. What is the ratio of the Revenue generated (in %) of Peru in 2009 to that in 2011?
Offer a terse response. 1.24. What is the ratio of the Revenue generated (in %) in Afghanistan in 2009 to that in 2012?
Ensure brevity in your answer.  0.33. What is the ratio of the Revenue generated (in %) in Denmark in 2009 to that in 2012?
Ensure brevity in your answer.  0.52. What is the ratio of the Revenue generated (in %) in Ireland in 2009 to that in 2012?
Offer a very short reply. 0.75. What is the ratio of the Revenue generated (in %) in Peru in 2009 to that in 2012?
Your answer should be very brief. 1.02. What is the ratio of the Revenue generated (in %) in Denmark in 2010 to that in 2011?
Give a very brief answer. 1. What is the ratio of the Revenue generated (in %) of Ireland in 2010 to that in 2011?
Your answer should be very brief. 0.71. What is the ratio of the Revenue generated (in %) in Peru in 2010 to that in 2011?
Your answer should be compact. 1.05. What is the ratio of the Revenue generated (in %) in Afghanistan in 2010 to that in 2012?
Your response must be concise. 0.79. What is the ratio of the Revenue generated (in %) in Denmark in 2010 to that in 2012?
Provide a short and direct response. 0.94. What is the ratio of the Revenue generated (in %) of Ireland in 2010 to that in 2012?
Your response must be concise. 0.69. What is the ratio of the Revenue generated (in %) in Peru in 2010 to that in 2012?
Make the answer very short. 0.86. What is the ratio of the Revenue generated (in %) in Afghanistan in 2011 to that in 2012?
Your answer should be compact. 0.79. What is the ratio of the Revenue generated (in %) of Denmark in 2011 to that in 2012?
Give a very brief answer. 0.93. What is the ratio of the Revenue generated (in %) in Ireland in 2011 to that in 2012?
Ensure brevity in your answer.  0.97. What is the ratio of the Revenue generated (in %) in Peru in 2011 to that in 2012?
Give a very brief answer. 0.82. What is the difference between the highest and the second highest Revenue generated (in %) of Afghanistan?
Offer a terse response. 1.86. What is the difference between the highest and the second highest Revenue generated (in %) of Denmark?
Keep it short and to the point. 0.59. What is the difference between the highest and the second highest Revenue generated (in %) in Ireland?
Offer a very short reply. 0.8. What is the difference between the highest and the second highest Revenue generated (in %) of Peru?
Give a very brief answer. 0.12. What is the difference between the highest and the lowest Revenue generated (in %) of Afghanistan?
Your response must be concise. 2.29. What is the difference between the highest and the lowest Revenue generated (in %) of Denmark?
Keep it short and to the point. 4.76. What is the difference between the highest and the lowest Revenue generated (in %) in Ireland?
Your answer should be very brief. 4.31. What is the difference between the highest and the lowest Revenue generated (in %) of Peru?
Keep it short and to the point. 1.26. 